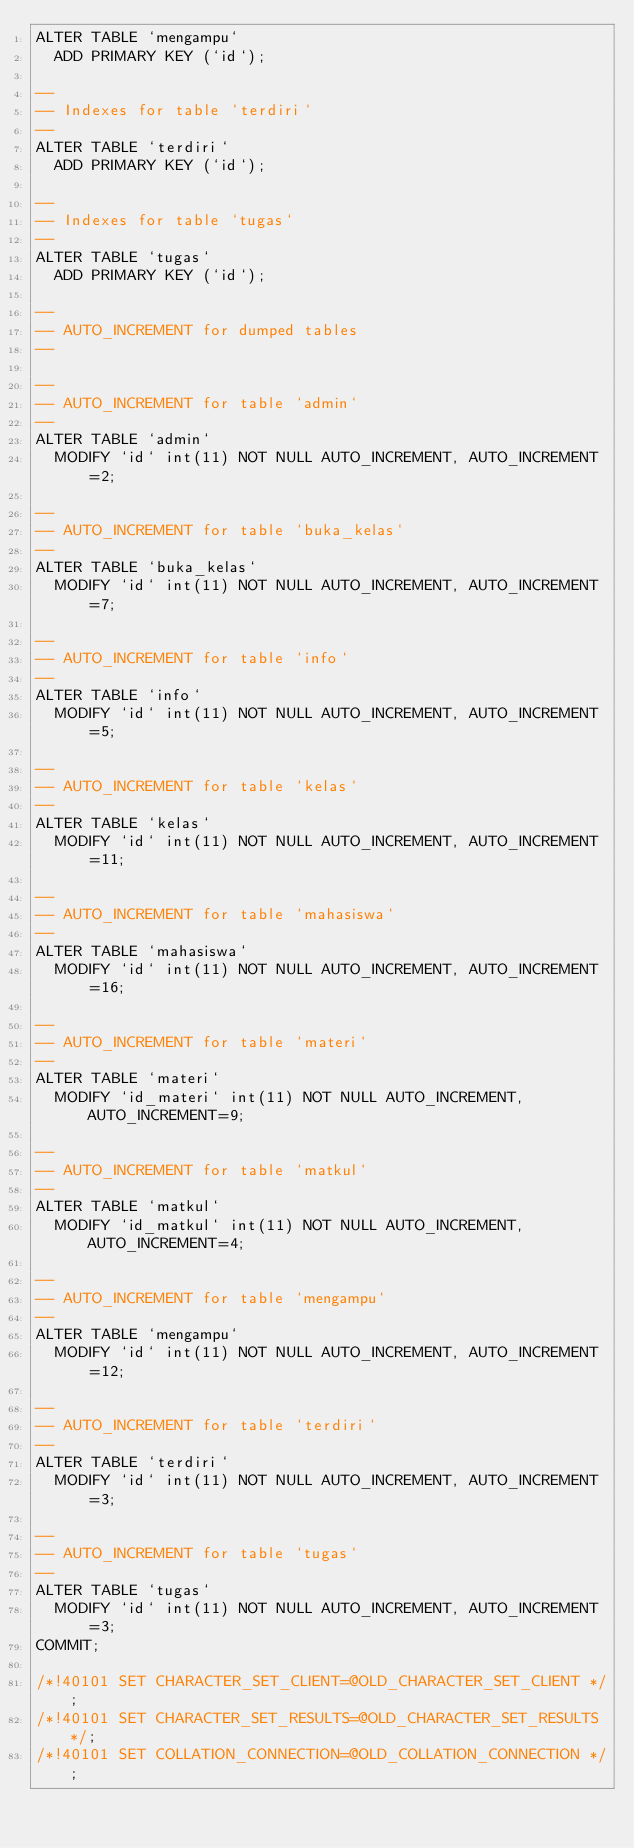<code> <loc_0><loc_0><loc_500><loc_500><_SQL_>ALTER TABLE `mengampu`
  ADD PRIMARY KEY (`id`);

--
-- Indexes for table `terdiri`
--
ALTER TABLE `terdiri`
  ADD PRIMARY KEY (`id`);

--
-- Indexes for table `tugas`
--
ALTER TABLE `tugas`
  ADD PRIMARY KEY (`id`);

--
-- AUTO_INCREMENT for dumped tables
--

--
-- AUTO_INCREMENT for table `admin`
--
ALTER TABLE `admin`
  MODIFY `id` int(11) NOT NULL AUTO_INCREMENT, AUTO_INCREMENT=2;

--
-- AUTO_INCREMENT for table `buka_kelas`
--
ALTER TABLE `buka_kelas`
  MODIFY `id` int(11) NOT NULL AUTO_INCREMENT, AUTO_INCREMENT=7;

--
-- AUTO_INCREMENT for table `info`
--
ALTER TABLE `info`
  MODIFY `id` int(11) NOT NULL AUTO_INCREMENT, AUTO_INCREMENT=5;

--
-- AUTO_INCREMENT for table `kelas`
--
ALTER TABLE `kelas`
  MODIFY `id` int(11) NOT NULL AUTO_INCREMENT, AUTO_INCREMENT=11;

--
-- AUTO_INCREMENT for table `mahasiswa`
--
ALTER TABLE `mahasiswa`
  MODIFY `id` int(11) NOT NULL AUTO_INCREMENT, AUTO_INCREMENT=16;

--
-- AUTO_INCREMENT for table `materi`
--
ALTER TABLE `materi`
  MODIFY `id_materi` int(11) NOT NULL AUTO_INCREMENT, AUTO_INCREMENT=9;

--
-- AUTO_INCREMENT for table `matkul`
--
ALTER TABLE `matkul`
  MODIFY `id_matkul` int(11) NOT NULL AUTO_INCREMENT, AUTO_INCREMENT=4;

--
-- AUTO_INCREMENT for table `mengampu`
--
ALTER TABLE `mengampu`
  MODIFY `id` int(11) NOT NULL AUTO_INCREMENT, AUTO_INCREMENT=12;

--
-- AUTO_INCREMENT for table `terdiri`
--
ALTER TABLE `terdiri`
  MODIFY `id` int(11) NOT NULL AUTO_INCREMENT, AUTO_INCREMENT=3;

--
-- AUTO_INCREMENT for table `tugas`
--
ALTER TABLE `tugas`
  MODIFY `id` int(11) NOT NULL AUTO_INCREMENT, AUTO_INCREMENT=3;
COMMIT;

/*!40101 SET CHARACTER_SET_CLIENT=@OLD_CHARACTER_SET_CLIENT */;
/*!40101 SET CHARACTER_SET_RESULTS=@OLD_CHARACTER_SET_RESULTS */;
/*!40101 SET COLLATION_CONNECTION=@OLD_COLLATION_CONNECTION */;
</code> 